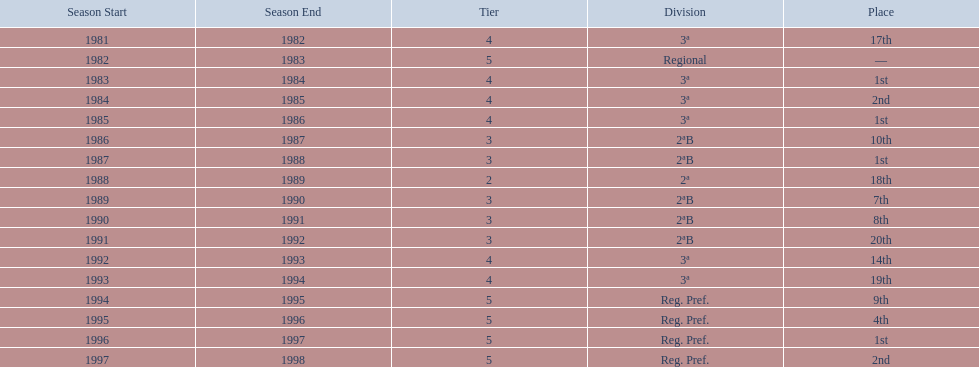What is the lowest place the team has come out? 20th. In what year did they come out in 20th place? 1991/92. 